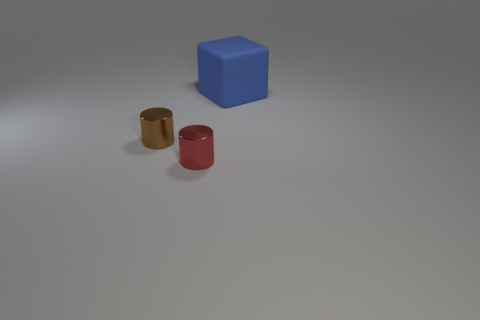Add 1 small red metal objects. How many objects exist? 4 Subtract all cylinders. How many objects are left? 1 Subtract 0 brown balls. How many objects are left? 3 Subtract all small brown metal things. Subtract all small metallic cylinders. How many objects are left? 0 Add 1 small brown objects. How many small brown objects are left? 2 Add 1 big green metallic cylinders. How many big green metallic cylinders exist? 1 